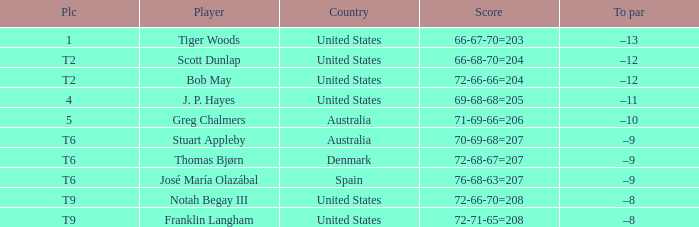What is the country of the player with a t6 place? Australia, Denmark, Spain. 